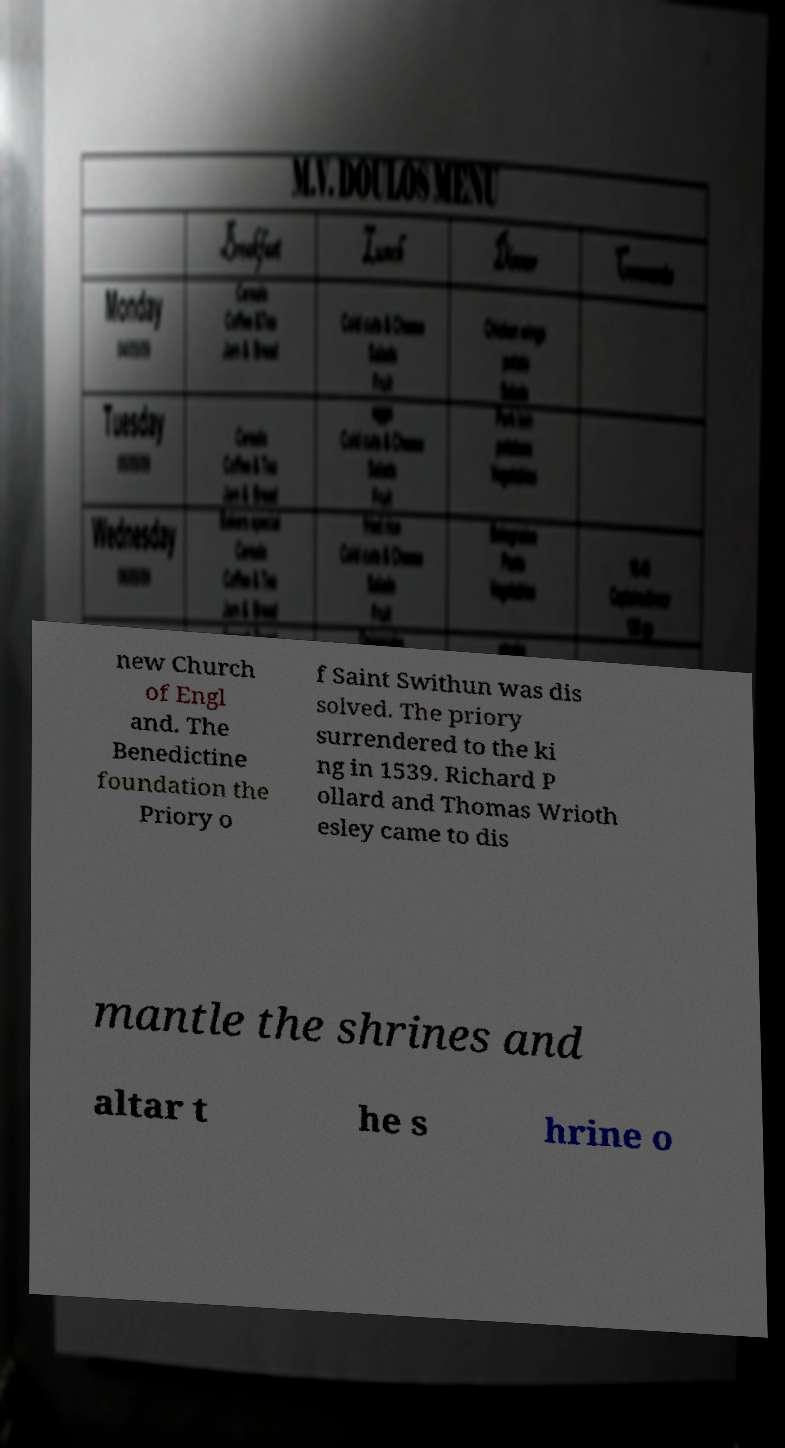Can you read and provide the text displayed in the image?This photo seems to have some interesting text. Can you extract and type it out for me? new Church of Engl and. The Benedictine foundation the Priory o f Saint Swithun was dis solved. The priory surrendered to the ki ng in 1539. Richard P ollard and Thomas Wrioth esley came to dis mantle the shrines and altar t he s hrine o 